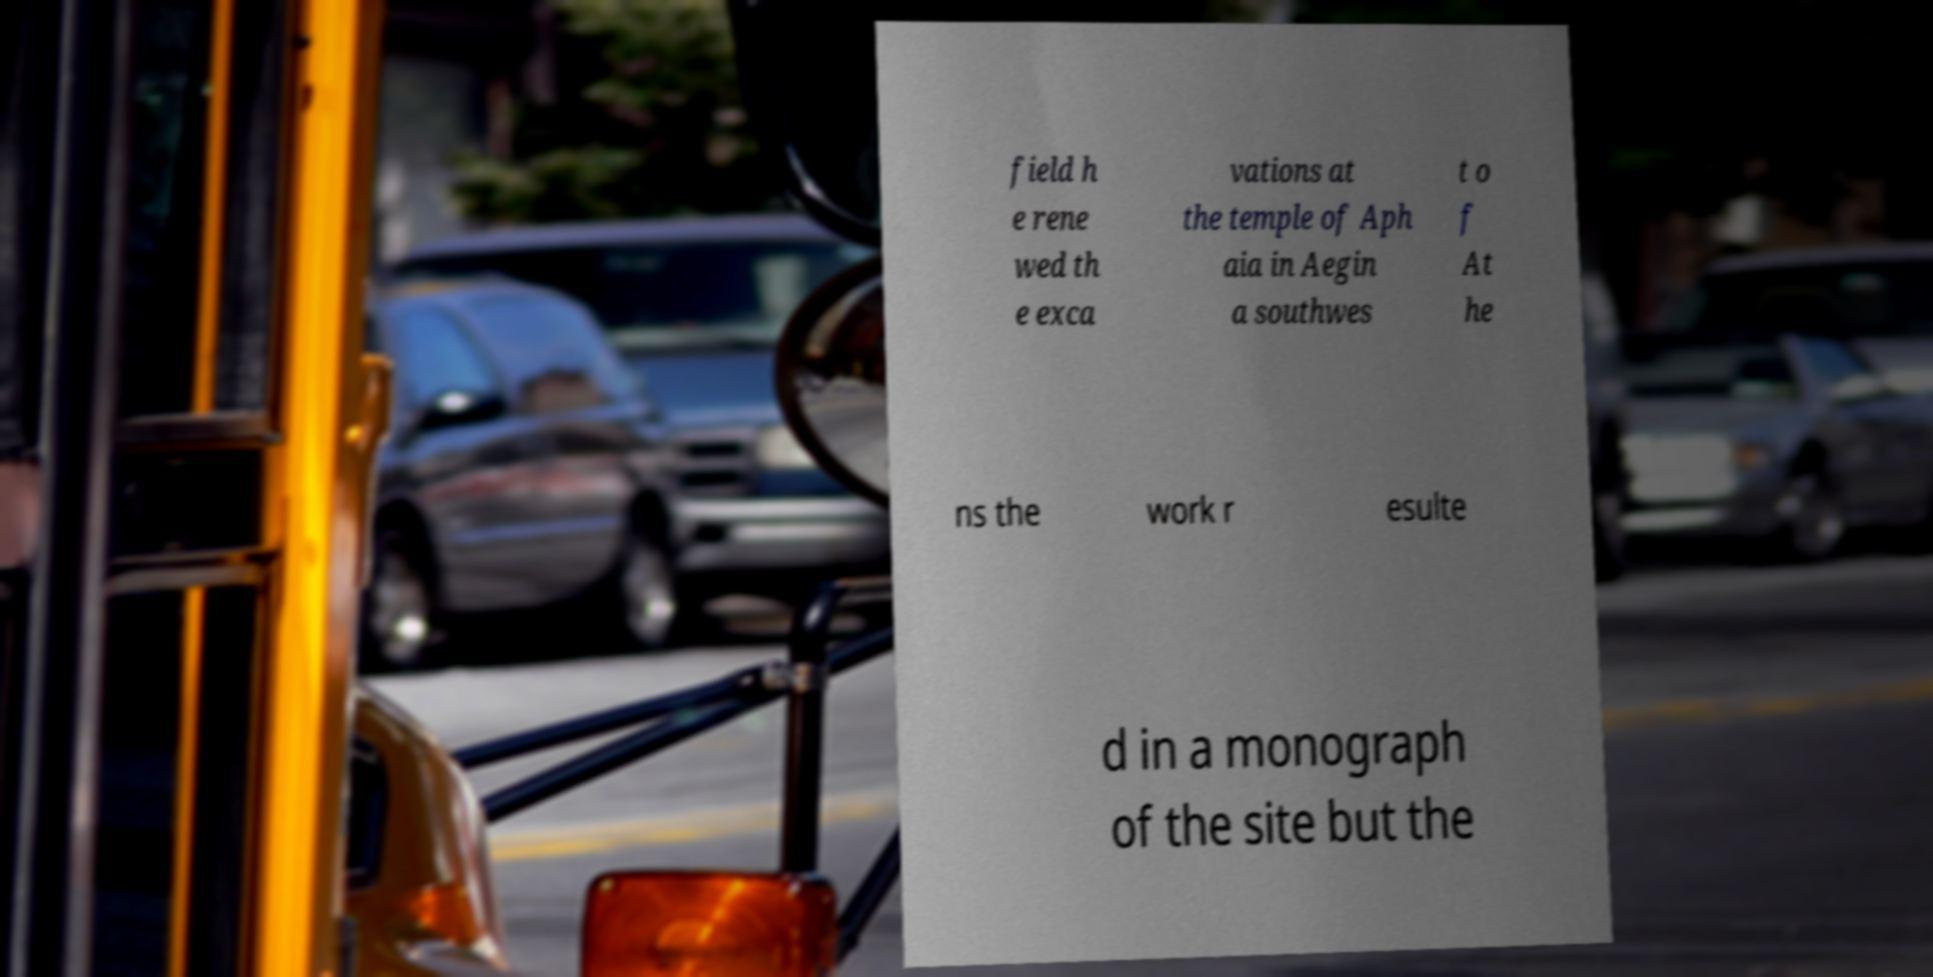What messages or text are displayed in this image? I need them in a readable, typed format. field h e rene wed th e exca vations at the temple of Aph aia in Aegin a southwes t o f At he ns the work r esulte d in a monograph of the site but the 